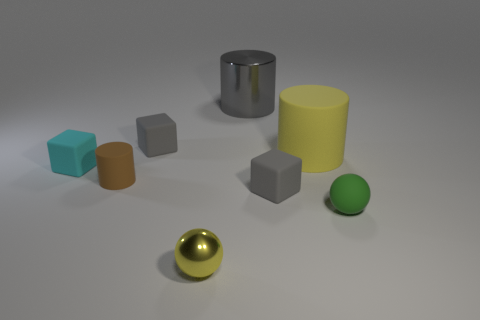Can you describe the colors and shapes of all the objects in the scene? Certainly! In the image, there is a variety of geometric shapes and colors. From left to right, there is a teal cube, a brown cylinder, two gray cubes, a large gray cylinder, a yellow cylinder, a golden sphere, and a small green sphere. The objects have a matte finish and are placed on a flat surface. 